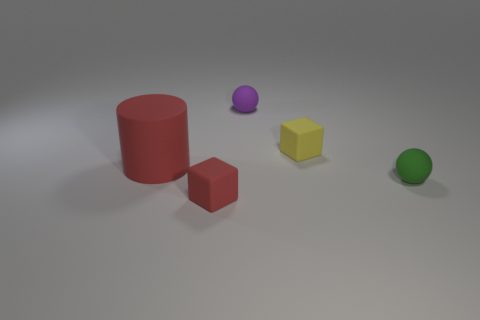Add 2 green matte spheres. How many objects exist? 7 Subtract all balls. How many objects are left? 3 Add 4 yellow matte things. How many yellow matte things are left? 5 Add 4 yellow rubber objects. How many yellow rubber objects exist? 5 Subtract 0 blue blocks. How many objects are left? 5 Subtract all rubber cylinders. Subtract all big rubber objects. How many objects are left? 3 